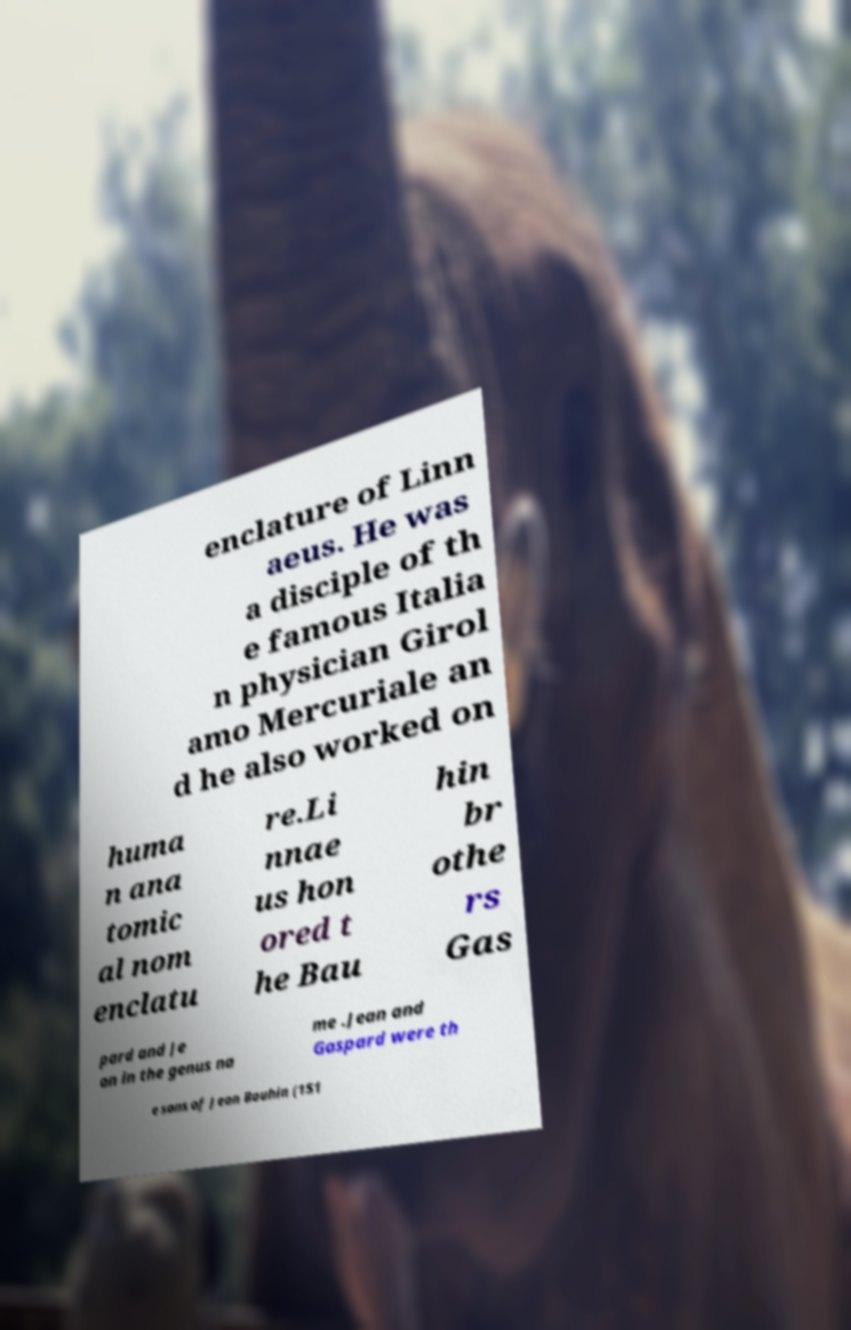Could you assist in decoding the text presented in this image and type it out clearly? enclature of Linn aeus. He was a disciple of th e famous Italia n physician Girol amo Mercuriale an d he also worked on huma n ana tomic al nom enclatu re.Li nnae us hon ored t he Bau hin br othe rs Gas pard and Je an in the genus na me .Jean and Gaspard were th e sons of Jean Bauhin (151 